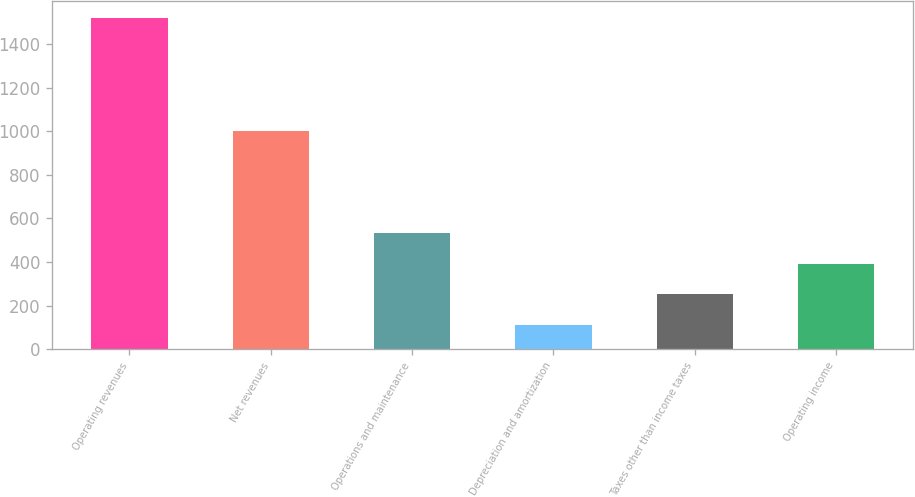Convert chart. <chart><loc_0><loc_0><loc_500><loc_500><bar_chart><fcel>Operating revenues<fcel>Net revenues<fcel>Operations and maintenance<fcel>Depreciation and amortization<fcel>Taxes other than income taxes<fcel>Operating income<nl><fcel>1521<fcel>1003<fcel>533.3<fcel>110<fcel>251.1<fcel>392.2<nl></chart> 